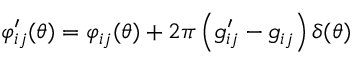Convert formula to latex. <formula><loc_0><loc_0><loc_500><loc_500>\varphi _ { i j } ^ { \prime } ( \theta ) = \varphi _ { i j } ( \theta ) + 2 \pi \left ( g _ { i j } ^ { \prime } - g _ { i j } \right ) \delta ( \theta )</formula> 